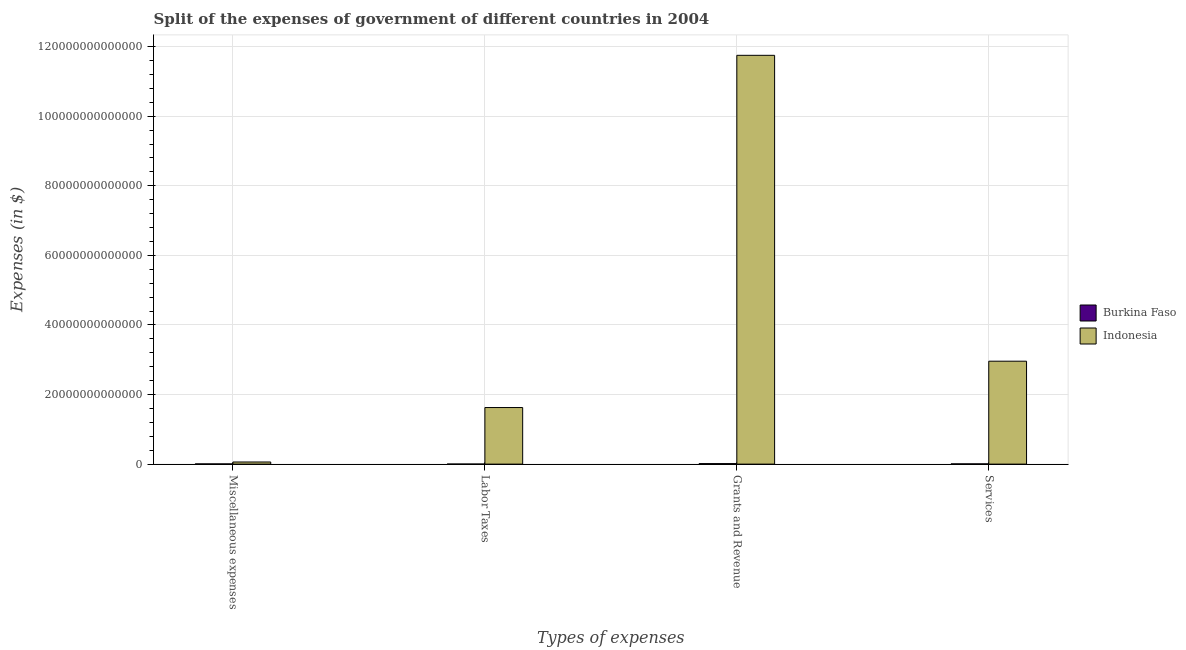How many different coloured bars are there?
Your response must be concise. 2. How many groups of bars are there?
Give a very brief answer. 4. Are the number of bars per tick equal to the number of legend labels?
Keep it short and to the point. Yes. How many bars are there on the 3rd tick from the left?
Your answer should be very brief. 2. What is the label of the 3rd group of bars from the left?
Give a very brief answer. Grants and Revenue. What is the amount spent on miscellaneous expenses in Burkina Faso?
Offer a very short reply. 5.59e+1. Across all countries, what is the maximum amount spent on labor taxes?
Offer a terse response. 1.63e+13. Across all countries, what is the minimum amount spent on labor taxes?
Provide a succinct answer. 1.11e+1. In which country was the amount spent on labor taxes maximum?
Offer a terse response. Indonesia. In which country was the amount spent on miscellaneous expenses minimum?
Ensure brevity in your answer.  Burkina Faso. What is the total amount spent on miscellaneous expenses in the graph?
Your response must be concise. 6.67e+11. What is the difference between the amount spent on labor taxes in Burkina Faso and that in Indonesia?
Make the answer very short. -1.62e+13. What is the difference between the amount spent on grants and revenue in Burkina Faso and the amount spent on services in Indonesia?
Give a very brief answer. -2.94e+13. What is the average amount spent on miscellaneous expenses per country?
Offer a terse response. 3.33e+11. What is the difference between the amount spent on miscellaneous expenses and amount spent on services in Indonesia?
Provide a short and direct response. -2.90e+13. In how many countries, is the amount spent on labor taxes greater than 56000000000000 $?
Give a very brief answer. 0. What is the ratio of the amount spent on services in Burkina Faso to that in Indonesia?
Your response must be concise. 0. Is the amount spent on grants and revenue in Indonesia less than that in Burkina Faso?
Provide a succinct answer. No. What is the difference between the highest and the second highest amount spent on miscellaneous expenses?
Provide a succinct answer. 5.55e+11. What is the difference between the highest and the lowest amount spent on labor taxes?
Offer a very short reply. 1.62e+13. Is the sum of the amount spent on miscellaneous expenses in Indonesia and Burkina Faso greater than the maximum amount spent on grants and revenue across all countries?
Ensure brevity in your answer.  No. What does the 1st bar from the left in Miscellaneous expenses represents?
Make the answer very short. Burkina Faso. What does the 1st bar from the right in Grants and Revenue represents?
Keep it short and to the point. Indonesia. What is the difference between two consecutive major ticks on the Y-axis?
Your answer should be compact. 2.00e+13. Are the values on the major ticks of Y-axis written in scientific E-notation?
Ensure brevity in your answer.  No. Does the graph contain grids?
Your answer should be compact. Yes. How many legend labels are there?
Your response must be concise. 2. How are the legend labels stacked?
Ensure brevity in your answer.  Vertical. What is the title of the graph?
Offer a very short reply. Split of the expenses of government of different countries in 2004. Does "Colombia" appear as one of the legend labels in the graph?
Keep it short and to the point. No. What is the label or title of the X-axis?
Give a very brief answer. Types of expenses. What is the label or title of the Y-axis?
Provide a short and direct response. Expenses (in $). What is the Expenses (in $) of Burkina Faso in Miscellaneous expenses?
Give a very brief answer. 5.59e+1. What is the Expenses (in $) of Indonesia in Miscellaneous expenses?
Offer a very short reply. 6.11e+11. What is the Expenses (in $) in Burkina Faso in Labor Taxes?
Keep it short and to the point. 1.11e+1. What is the Expenses (in $) in Indonesia in Labor Taxes?
Make the answer very short. 1.63e+13. What is the Expenses (in $) in Burkina Faso in Grants and Revenue?
Your answer should be compact. 1.44e+11. What is the Expenses (in $) in Indonesia in Grants and Revenue?
Offer a terse response. 1.17e+14. What is the Expenses (in $) in Burkina Faso in Services?
Your answer should be very brief. 6.73e+1. What is the Expenses (in $) of Indonesia in Services?
Keep it short and to the point. 2.96e+13. Across all Types of expenses, what is the maximum Expenses (in $) in Burkina Faso?
Offer a terse response. 1.44e+11. Across all Types of expenses, what is the maximum Expenses (in $) in Indonesia?
Your answer should be very brief. 1.17e+14. Across all Types of expenses, what is the minimum Expenses (in $) in Burkina Faso?
Give a very brief answer. 1.11e+1. Across all Types of expenses, what is the minimum Expenses (in $) in Indonesia?
Your response must be concise. 6.11e+11. What is the total Expenses (in $) of Burkina Faso in the graph?
Keep it short and to the point. 2.78e+11. What is the total Expenses (in $) of Indonesia in the graph?
Your response must be concise. 1.64e+14. What is the difference between the Expenses (in $) in Burkina Faso in Miscellaneous expenses and that in Labor Taxes?
Make the answer very short. 4.48e+1. What is the difference between the Expenses (in $) in Indonesia in Miscellaneous expenses and that in Labor Taxes?
Offer a terse response. -1.56e+13. What is the difference between the Expenses (in $) in Burkina Faso in Miscellaneous expenses and that in Grants and Revenue?
Provide a succinct answer. -8.77e+1. What is the difference between the Expenses (in $) of Indonesia in Miscellaneous expenses and that in Grants and Revenue?
Keep it short and to the point. -1.17e+14. What is the difference between the Expenses (in $) of Burkina Faso in Miscellaneous expenses and that in Services?
Keep it short and to the point. -1.14e+1. What is the difference between the Expenses (in $) of Indonesia in Miscellaneous expenses and that in Services?
Offer a very short reply. -2.90e+13. What is the difference between the Expenses (in $) in Burkina Faso in Labor Taxes and that in Grants and Revenue?
Provide a short and direct response. -1.32e+11. What is the difference between the Expenses (in $) of Indonesia in Labor Taxes and that in Grants and Revenue?
Offer a terse response. -1.01e+14. What is the difference between the Expenses (in $) in Burkina Faso in Labor Taxes and that in Services?
Your answer should be compact. -5.62e+1. What is the difference between the Expenses (in $) in Indonesia in Labor Taxes and that in Services?
Offer a very short reply. -1.33e+13. What is the difference between the Expenses (in $) in Burkina Faso in Grants and Revenue and that in Services?
Provide a succinct answer. 7.62e+1. What is the difference between the Expenses (in $) in Indonesia in Grants and Revenue and that in Services?
Ensure brevity in your answer.  8.79e+13. What is the difference between the Expenses (in $) of Burkina Faso in Miscellaneous expenses and the Expenses (in $) of Indonesia in Labor Taxes?
Provide a short and direct response. -1.62e+13. What is the difference between the Expenses (in $) in Burkina Faso in Miscellaneous expenses and the Expenses (in $) in Indonesia in Grants and Revenue?
Offer a very short reply. -1.17e+14. What is the difference between the Expenses (in $) of Burkina Faso in Miscellaneous expenses and the Expenses (in $) of Indonesia in Services?
Keep it short and to the point. -2.95e+13. What is the difference between the Expenses (in $) in Burkina Faso in Labor Taxes and the Expenses (in $) in Indonesia in Grants and Revenue?
Your answer should be very brief. -1.17e+14. What is the difference between the Expenses (in $) in Burkina Faso in Labor Taxes and the Expenses (in $) in Indonesia in Services?
Give a very brief answer. -2.96e+13. What is the difference between the Expenses (in $) of Burkina Faso in Grants and Revenue and the Expenses (in $) of Indonesia in Services?
Offer a very short reply. -2.94e+13. What is the average Expenses (in $) of Burkina Faso per Types of expenses?
Provide a short and direct response. 6.95e+1. What is the average Expenses (in $) of Indonesia per Types of expenses?
Offer a terse response. 4.10e+13. What is the difference between the Expenses (in $) in Burkina Faso and Expenses (in $) in Indonesia in Miscellaneous expenses?
Make the answer very short. -5.55e+11. What is the difference between the Expenses (in $) of Burkina Faso and Expenses (in $) of Indonesia in Labor Taxes?
Offer a terse response. -1.62e+13. What is the difference between the Expenses (in $) in Burkina Faso and Expenses (in $) in Indonesia in Grants and Revenue?
Offer a very short reply. -1.17e+14. What is the difference between the Expenses (in $) in Burkina Faso and Expenses (in $) in Indonesia in Services?
Keep it short and to the point. -2.95e+13. What is the ratio of the Expenses (in $) of Burkina Faso in Miscellaneous expenses to that in Labor Taxes?
Your response must be concise. 5.03. What is the ratio of the Expenses (in $) of Indonesia in Miscellaneous expenses to that in Labor Taxes?
Provide a succinct answer. 0.04. What is the ratio of the Expenses (in $) of Burkina Faso in Miscellaneous expenses to that in Grants and Revenue?
Provide a short and direct response. 0.39. What is the ratio of the Expenses (in $) of Indonesia in Miscellaneous expenses to that in Grants and Revenue?
Give a very brief answer. 0.01. What is the ratio of the Expenses (in $) of Burkina Faso in Miscellaneous expenses to that in Services?
Ensure brevity in your answer.  0.83. What is the ratio of the Expenses (in $) in Indonesia in Miscellaneous expenses to that in Services?
Your answer should be very brief. 0.02. What is the ratio of the Expenses (in $) of Burkina Faso in Labor Taxes to that in Grants and Revenue?
Your response must be concise. 0.08. What is the ratio of the Expenses (in $) in Indonesia in Labor Taxes to that in Grants and Revenue?
Your answer should be compact. 0.14. What is the ratio of the Expenses (in $) of Burkina Faso in Labor Taxes to that in Services?
Give a very brief answer. 0.16. What is the ratio of the Expenses (in $) in Indonesia in Labor Taxes to that in Services?
Keep it short and to the point. 0.55. What is the ratio of the Expenses (in $) of Burkina Faso in Grants and Revenue to that in Services?
Offer a very short reply. 2.13. What is the ratio of the Expenses (in $) in Indonesia in Grants and Revenue to that in Services?
Ensure brevity in your answer.  3.97. What is the difference between the highest and the second highest Expenses (in $) in Burkina Faso?
Your answer should be very brief. 7.62e+1. What is the difference between the highest and the second highest Expenses (in $) in Indonesia?
Keep it short and to the point. 8.79e+13. What is the difference between the highest and the lowest Expenses (in $) in Burkina Faso?
Give a very brief answer. 1.32e+11. What is the difference between the highest and the lowest Expenses (in $) of Indonesia?
Provide a succinct answer. 1.17e+14. 